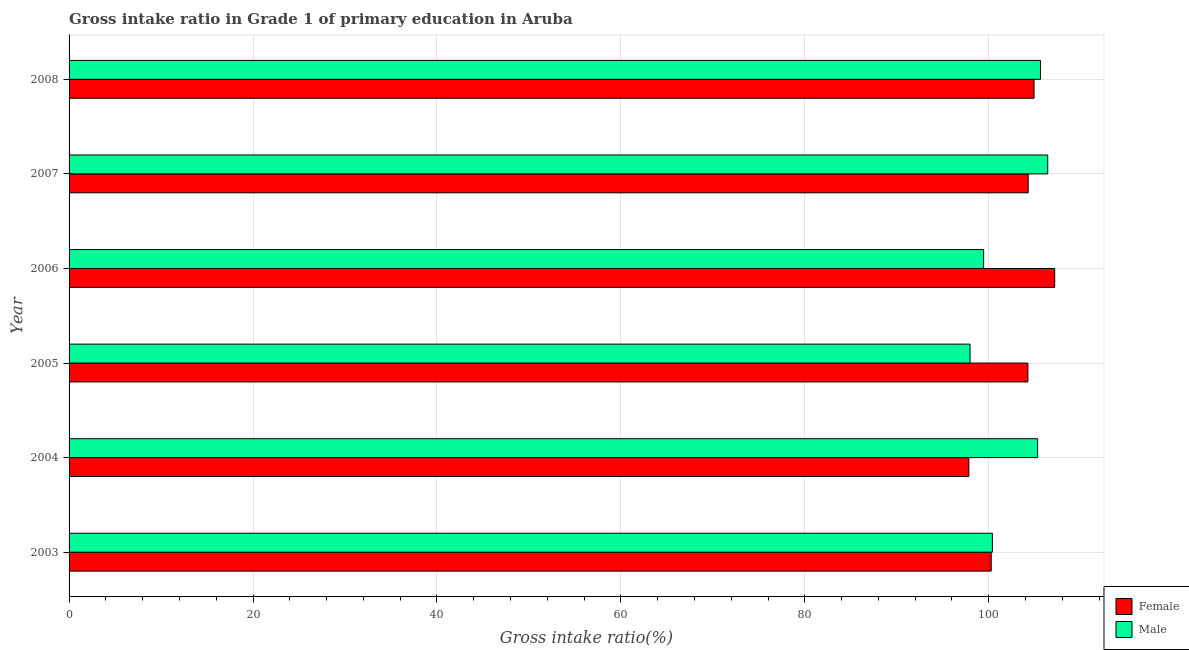How many groups of bars are there?
Keep it short and to the point. 6. Are the number of bars per tick equal to the number of legend labels?
Give a very brief answer. Yes. How many bars are there on the 3rd tick from the bottom?
Provide a succinct answer. 2. What is the gross intake ratio(female) in 2004?
Your response must be concise. 97.84. Across all years, what is the maximum gross intake ratio(female)?
Ensure brevity in your answer.  107.17. Across all years, what is the minimum gross intake ratio(male)?
Your response must be concise. 97.97. In which year was the gross intake ratio(male) maximum?
Keep it short and to the point. 2007. What is the total gross intake ratio(female) in the graph?
Make the answer very short. 618.76. What is the difference between the gross intake ratio(female) in 2003 and that in 2004?
Provide a short and direct response. 2.43. What is the difference between the gross intake ratio(female) in 2004 and the gross intake ratio(male) in 2007?
Ensure brevity in your answer.  -8.58. What is the average gross intake ratio(male) per year?
Your response must be concise. 102.53. In the year 2008, what is the difference between the gross intake ratio(male) and gross intake ratio(female)?
Make the answer very short. 0.7. In how many years, is the gross intake ratio(female) greater than 64 %?
Ensure brevity in your answer.  6. What is the ratio of the gross intake ratio(male) in 2004 to that in 2005?
Offer a very short reply. 1.07. Is the gross intake ratio(male) in 2006 less than that in 2008?
Keep it short and to the point. Yes. What is the difference between the highest and the second highest gross intake ratio(male)?
Keep it short and to the point. 0.79. What is the difference between the highest and the lowest gross intake ratio(female)?
Ensure brevity in your answer.  9.34. What does the 2nd bar from the top in 2005 represents?
Give a very brief answer. Female. How many years are there in the graph?
Your response must be concise. 6. What is the difference between two consecutive major ticks on the X-axis?
Ensure brevity in your answer.  20. Does the graph contain grids?
Your response must be concise. Yes. How are the legend labels stacked?
Your answer should be compact. Vertical. What is the title of the graph?
Your answer should be compact. Gross intake ratio in Grade 1 of primary education in Aruba. Does "Attending school" appear as one of the legend labels in the graph?
Ensure brevity in your answer.  No. What is the label or title of the X-axis?
Your response must be concise. Gross intake ratio(%). What is the label or title of the Y-axis?
Give a very brief answer. Year. What is the Gross intake ratio(%) in Female in 2003?
Your answer should be compact. 100.27. What is the Gross intake ratio(%) in Male in 2003?
Offer a terse response. 100.4. What is the Gross intake ratio(%) in Female in 2004?
Keep it short and to the point. 97.84. What is the Gross intake ratio(%) in Male in 2004?
Make the answer very short. 105.32. What is the Gross intake ratio(%) of Female in 2005?
Provide a short and direct response. 104.26. What is the Gross intake ratio(%) in Male in 2005?
Your answer should be compact. 97.97. What is the Gross intake ratio(%) of Female in 2006?
Offer a very short reply. 107.17. What is the Gross intake ratio(%) in Male in 2006?
Provide a succinct answer. 99.45. What is the Gross intake ratio(%) in Female in 2007?
Your response must be concise. 104.29. What is the Gross intake ratio(%) of Male in 2007?
Make the answer very short. 106.42. What is the Gross intake ratio(%) of Female in 2008?
Ensure brevity in your answer.  104.93. What is the Gross intake ratio(%) in Male in 2008?
Provide a succinct answer. 105.63. Across all years, what is the maximum Gross intake ratio(%) in Female?
Your response must be concise. 107.17. Across all years, what is the maximum Gross intake ratio(%) of Male?
Offer a terse response. 106.42. Across all years, what is the minimum Gross intake ratio(%) in Female?
Your answer should be compact. 97.84. Across all years, what is the minimum Gross intake ratio(%) of Male?
Your answer should be very brief. 97.97. What is the total Gross intake ratio(%) in Female in the graph?
Offer a terse response. 618.76. What is the total Gross intake ratio(%) in Male in the graph?
Give a very brief answer. 615.17. What is the difference between the Gross intake ratio(%) of Female in 2003 and that in 2004?
Give a very brief answer. 2.43. What is the difference between the Gross intake ratio(%) in Male in 2003 and that in 2004?
Your answer should be compact. -4.92. What is the difference between the Gross intake ratio(%) of Female in 2003 and that in 2005?
Ensure brevity in your answer.  -3.99. What is the difference between the Gross intake ratio(%) of Male in 2003 and that in 2005?
Your answer should be compact. 2.43. What is the difference between the Gross intake ratio(%) of Female in 2003 and that in 2006?
Offer a very short reply. -6.9. What is the difference between the Gross intake ratio(%) of Male in 2003 and that in 2006?
Your answer should be compact. 0.95. What is the difference between the Gross intake ratio(%) of Female in 2003 and that in 2007?
Offer a terse response. -4.02. What is the difference between the Gross intake ratio(%) in Male in 2003 and that in 2007?
Your answer should be very brief. -6.02. What is the difference between the Gross intake ratio(%) of Female in 2003 and that in 2008?
Offer a terse response. -4.66. What is the difference between the Gross intake ratio(%) in Male in 2003 and that in 2008?
Offer a terse response. -5.23. What is the difference between the Gross intake ratio(%) of Female in 2004 and that in 2005?
Your answer should be very brief. -6.42. What is the difference between the Gross intake ratio(%) in Male in 2004 and that in 2005?
Provide a succinct answer. 7.35. What is the difference between the Gross intake ratio(%) in Female in 2004 and that in 2006?
Your response must be concise. -9.34. What is the difference between the Gross intake ratio(%) in Male in 2004 and that in 2006?
Offer a very short reply. 5.87. What is the difference between the Gross intake ratio(%) of Female in 2004 and that in 2007?
Give a very brief answer. -6.45. What is the difference between the Gross intake ratio(%) in Male in 2004 and that in 2007?
Offer a very short reply. -1.1. What is the difference between the Gross intake ratio(%) of Female in 2004 and that in 2008?
Provide a short and direct response. -7.09. What is the difference between the Gross intake ratio(%) in Male in 2004 and that in 2008?
Your answer should be very brief. -0.31. What is the difference between the Gross intake ratio(%) in Female in 2005 and that in 2006?
Offer a terse response. -2.91. What is the difference between the Gross intake ratio(%) of Male in 2005 and that in 2006?
Provide a short and direct response. -1.48. What is the difference between the Gross intake ratio(%) of Female in 2005 and that in 2007?
Your response must be concise. -0.03. What is the difference between the Gross intake ratio(%) of Male in 2005 and that in 2007?
Your answer should be compact. -8.45. What is the difference between the Gross intake ratio(%) of Female in 2005 and that in 2008?
Provide a short and direct response. -0.67. What is the difference between the Gross intake ratio(%) of Male in 2005 and that in 2008?
Keep it short and to the point. -7.66. What is the difference between the Gross intake ratio(%) in Female in 2006 and that in 2007?
Provide a succinct answer. 2.88. What is the difference between the Gross intake ratio(%) in Male in 2006 and that in 2007?
Provide a succinct answer. -6.97. What is the difference between the Gross intake ratio(%) in Female in 2006 and that in 2008?
Ensure brevity in your answer.  2.25. What is the difference between the Gross intake ratio(%) in Male in 2006 and that in 2008?
Keep it short and to the point. -6.18. What is the difference between the Gross intake ratio(%) of Female in 2007 and that in 2008?
Ensure brevity in your answer.  -0.64. What is the difference between the Gross intake ratio(%) in Male in 2007 and that in 2008?
Your answer should be very brief. 0.79. What is the difference between the Gross intake ratio(%) of Female in 2003 and the Gross intake ratio(%) of Male in 2004?
Ensure brevity in your answer.  -5.05. What is the difference between the Gross intake ratio(%) of Female in 2003 and the Gross intake ratio(%) of Male in 2005?
Make the answer very short. 2.3. What is the difference between the Gross intake ratio(%) in Female in 2003 and the Gross intake ratio(%) in Male in 2006?
Your answer should be compact. 0.82. What is the difference between the Gross intake ratio(%) in Female in 2003 and the Gross intake ratio(%) in Male in 2007?
Provide a short and direct response. -6.15. What is the difference between the Gross intake ratio(%) of Female in 2003 and the Gross intake ratio(%) of Male in 2008?
Provide a succinct answer. -5.36. What is the difference between the Gross intake ratio(%) of Female in 2004 and the Gross intake ratio(%) of Male in 2005?
Give a very brief answer. -0.13. What is the difference between the Gross intake ratio(%) in Female in 2004 and the Gross intake ratio(%) in Male in 2006?
Give a very brief answer. -1.61. What is the difference between the Gross intake ratio(%) of Female in 2004 and the Gross intake ratio(%) of Male in 2007?
Provide a succinct answer. -8.58. What is the difference between the Gross intake ratio(%) of Female in 2004 and the Gross intake ratio(%) of Male in 2008?
Your answer should be compact. -7.79. What is the difference between the Gross intake ratio(%) in Female in 2005 and the Gross intake ratio(%) in Male in 2006?
Provide a succinct answer. 4.81. What is the difference between the Gross intake ratio(%) of Female in 2005 and the Gross intake ratio(%) of Male in 2007?
Ensure brevity in your answer.  -2.16. What is the difference between the Gross intake ratio(%) in Female in 2005 and the Gross intake ratio(%) in Male in 2008?
Provide a succinct answer. -1.37. What is the difference between the Gross intake ratio(%) in Female in 2006 and the Gross intake ratio(%) in Male in 2007?
Offer a terse response. 0.76. What is the difference between the Gross intake ratio(%) in Female in 2006 and the Gross intake ratio(%) in Male in 2008?
Give a very brief answer. 1.55. What is the difference between the Gross intake ratio(%) in Female in 2007 and the Gross intake ratio(%) in Male in 2008?
Give a very brief answer. -1.33. What is the average Gross intake ratio(%) in Female per year?
Keep it short and to the point. 103.13. What is the average Gross intake ratio(%) in Male per year?
Your answer should be very brief. 102.53. In the year 2003, what is the difference between the Gross intake ratio(%) of Female and Gross intake ratio(%) of Male?
Ensure brevity in your answer.  -0.13. In the year 2004, what is the difference between the Gross intake ratio(%) in Female and Gross intake ratio(%) in Male?
Your answer should be compact. -7.48. In the year 2005, what is the difference between the Gross intake ratio(%) of Female and Gross intake ratio(%) of Male?
Offer a very short reply. 6.29. In the year 2006, what is the difference between the Gross intake ratio(%) of Female and Gross intake ratio(%) of Male?
Ensure brevity in your answer.  7.73. In the year 2007, what is the difference between the Gross intake ratio(%) in Female and Gross intake ratio(%) in Male?
Provide a short and direct response. -2.12. In the year 2008, what is the difference between the Gross intake ratio(%) of Female and Gross intake ratio(%) of Male?
Offer a very short reply. -0.7. What is the ratio of the Gross intake ratio(%) in Female in 2003 to that in 2004?
Provide a short and direct response. 1.02. What is the ratio of the Gross intake ratio(%) in Male in 2003 to that in 2004?
Keep it short and to the point. 0.95. What is the ratio of the Gross intake ratio(%) in Female in 2003 to that in 2005?
Your response must be concise. 0.96. What is the ratio of the Gross intake ratio(%) of Male in 2003 to that in 2005?
Provide a short and direct response. 1.02. What is the ratio of the Gross intake ratio(%) of Female in 2003 to that in 2006?
Give a very brief answer. 0.94. What is the ratio of the Gross intake ratio(%) of Male in 2003 to that in 2006?
Give a very brief answer. 1.01. What is the ratio of the Gross intake ratio(%) in Female in 2003 to that in 2007?
Provide a short and direct response. 0.96. What is the ratio of the Gross intake ratio(%) of Male in 2003 to that in 2007?
Offer a very short reply. 0.94. What is the ratio of the Gross intake ratio(%) in Female in 2003 to that in 2008?
Your answer should be very brief. 0.96. What is the ratio of the Gross intake ratio(%) of Male in 2003 to that in 2008?
Your answer should be very brief. 0.95. What is the ratio of the Gross intake ratio(%) in Female in 2004 to that in 2005?
Your response must be concise. 0.94. What is the ratio of the Gross intake ratio(%) of Male in 2004 to that in 2005?
Provide a succinct answer. 1.07. What is the ratio of the Gross intake ratio(%) in Female in 2004 to that in 2006?
Offer a very short reply. 0.91. What is the ratio of the Gross intake ratio(%) in Male in 2004 to that in 2006?
Provide a short and direct response. 1.06. What is the ratio of the Gross intake ratio(%) in Female in 2004 to that in 2007?
Give a very brief answer. 0.94. What is the ratio of the Gross intake ratio(%) in Female in 2004 to that in 2008?
Give a very brief answer. 0.93. What is the ratio of the Gross intake ratio(%) of Male in 2004 to that in 2008?
Offer a terse response. 1. What is the ratio of the Gross intake ratio(%) in Female in 2005 to that in 2006?
Provide a short and direct response. 0.97. What is the ratio of the Gross intake ratio(%) of Male in 2005 to that in 2006?
Your answer should be very brief. 0.99. What is the ratio of the Gross intake ratio(%) of Female in 2005 to that in 2007?
Your answer should be very brief. 1. What is the ratio of the Gross intake ratio(%) of Male in 2005 to that in 2007?
Provide a succinct answer. 0.92. What is the ratio of the Gross intake ratio(%) in Male in 2005 to that in 2008?
Your answer should be compact. 0.93. What is the ratio of the Gross intake ratio(%) in Female in 2006 to that in 2007?
Offer a very short reply. 1.03. What is the ratio of the Gross intake ratio(%) of Male in 2006 to that in 2007?
Offer a terse response. 0.93. What is the ratio of the Gross intake ratio(%) of Female in 2006 to that in 2008?
Offer a terse response. 1.02. What is the ratio of the Gross intake ratio(%) in Male in 2006 to that in 2008?
Give a very brief answer. 0.94. What is the ratio of the Gross intake ratio(%) in Male in 2007 to that in 2008?
Provide a succinct answer. 1.01. What is the difference between the highest and the second highest Gross intake ratio(%) in Female?
Keep it short and to the point. 2.25. What is the difference between the highest and the second highest Gross intake ratio(%) of Male?
Provide a short and direct response. 0.79. What is the difference between the highest and the lowest Gross intake ratio(%) in Female?
Keep it short and to the point. 9.34. What is the difference between the highest and the lowest Gross intake ratio(%) of Male?
Your answer should be very brief. 8.45. 